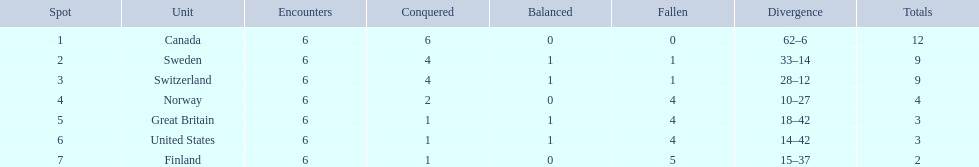Which country finished below the united states? Finland. 